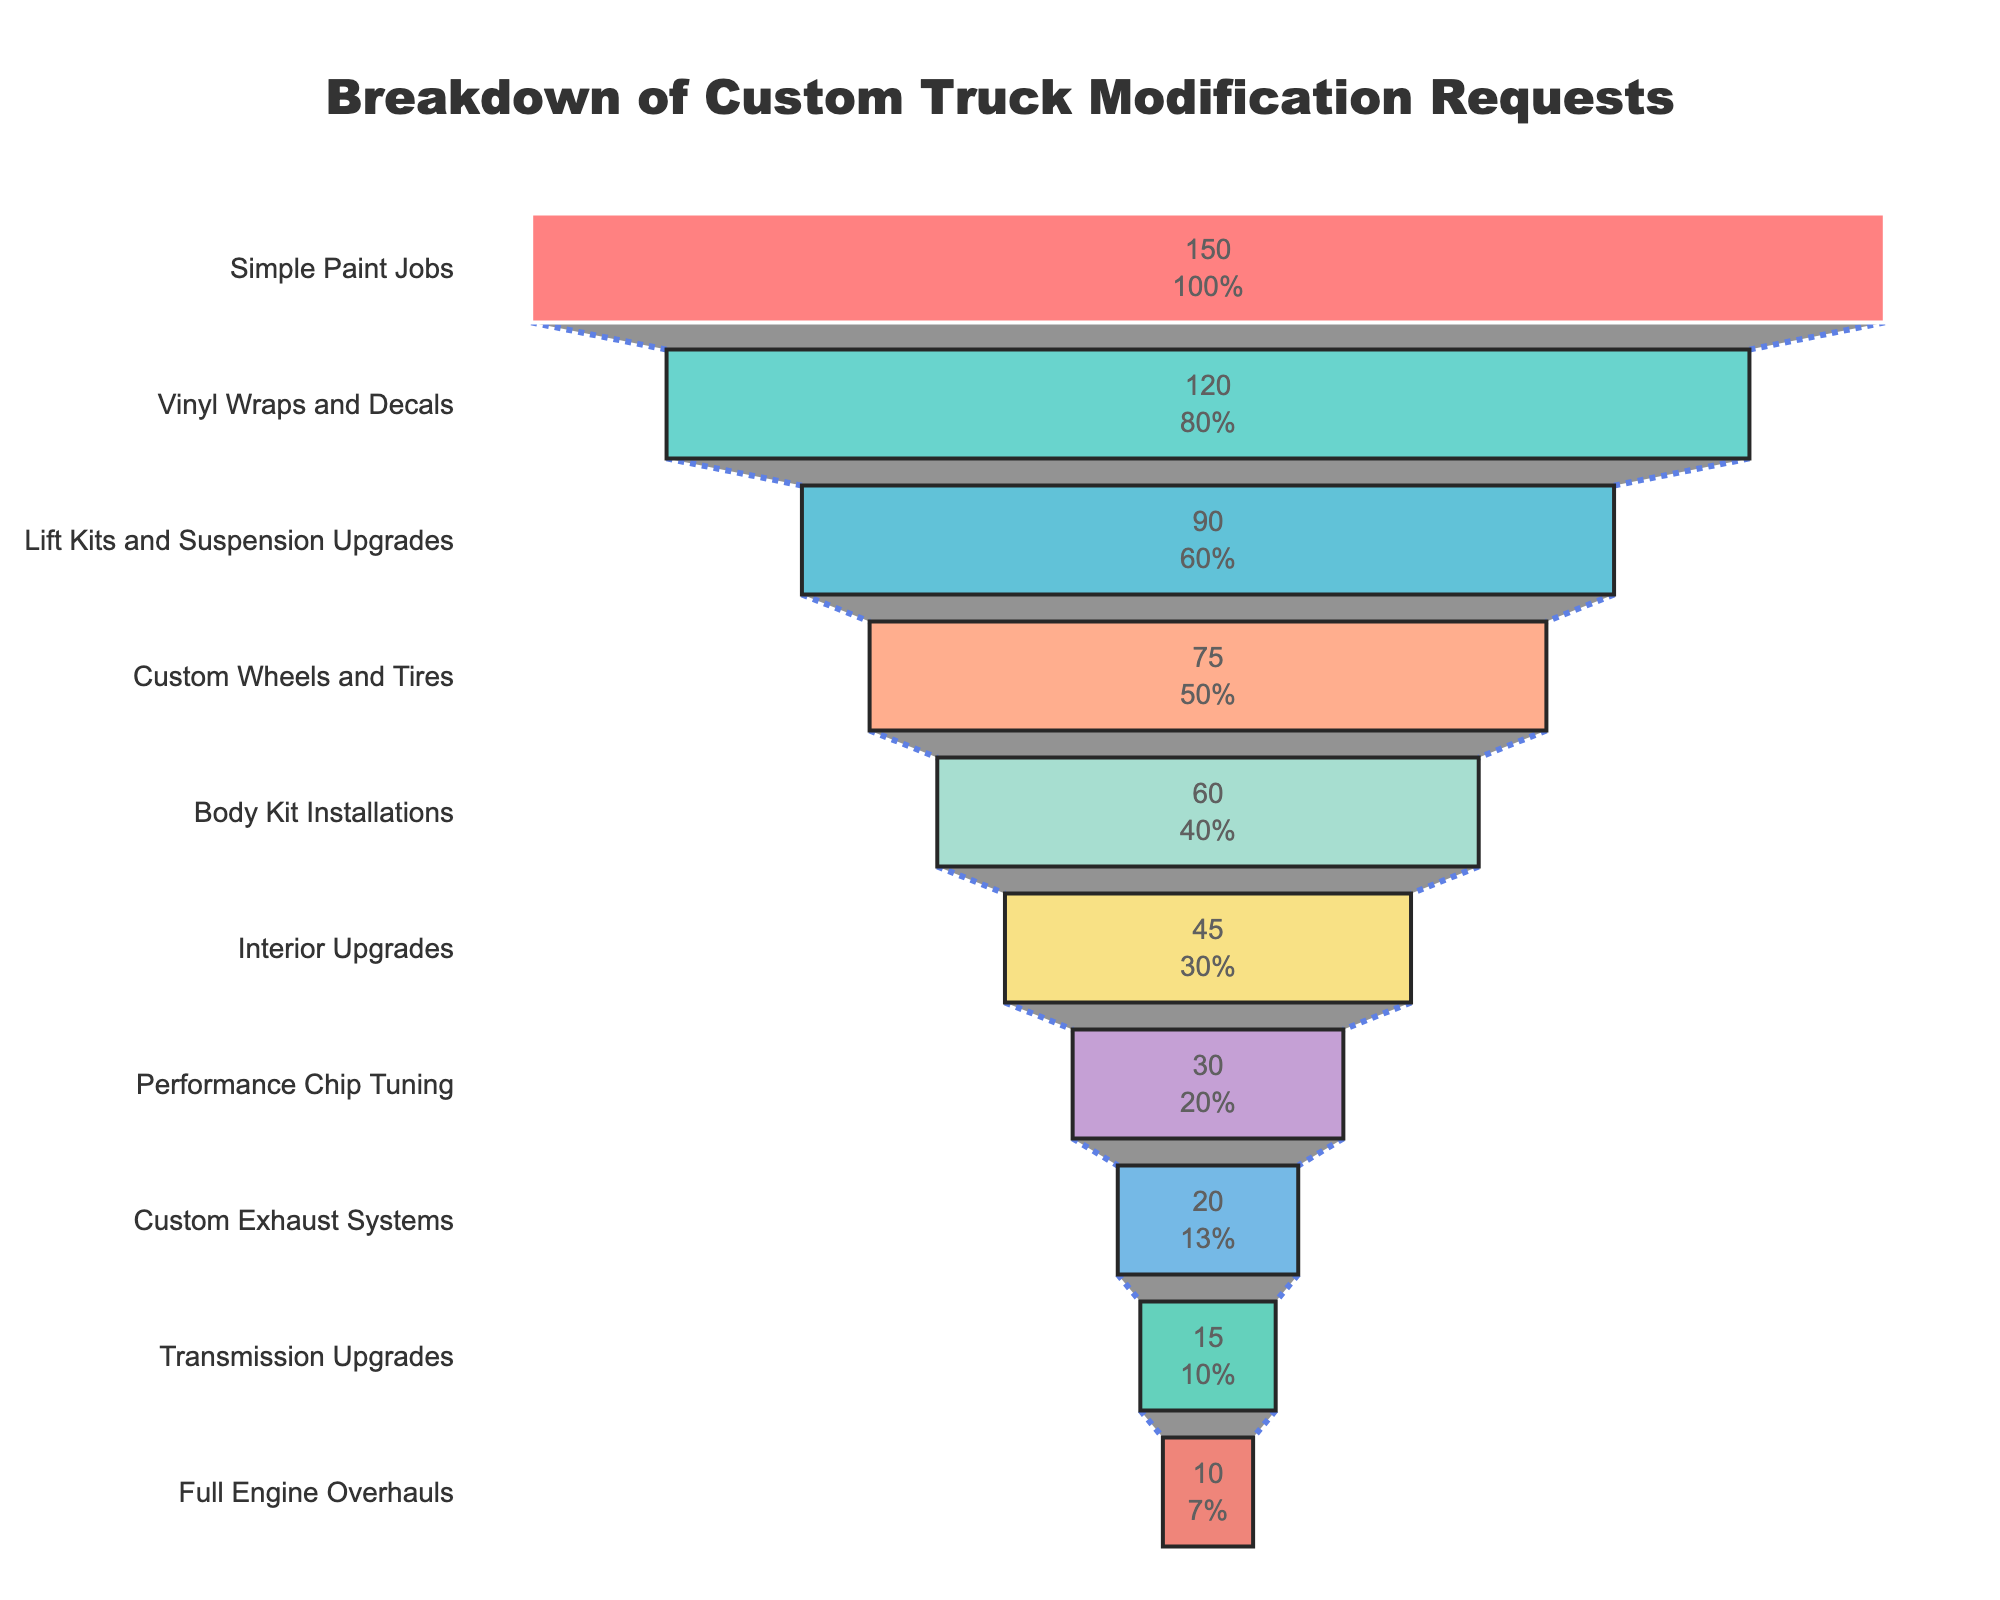What is the title of the chart? The title of the chart is located at the top and usually presents an overview of the chart's content. The title here is "Breakdown of Custom Truck Modification Requests".
Answer: Breakdown of Custom Truck Modification Requests Which modification type has the highest number of requests? The modification type with the highest number of requests is positioned at the widest part at the top of the funnel chart. It is labeled "Simple Paint Jobs" with 150 requests.
Answer: Simple Paint Jobs How many types of custom truck modifications are listed in the chart? The number of distinct modification types can be determined by counting each distinct section of the funnel chart from top to bottom. There are 10 different modification types listed.
Answer: 10 What percentage of total requests are for Lift Kits and Suspension Upgrades? The number of requests for Lift Kits and Suspension Upgrades is 90. To find the percentage, divide this by the total number of requests for all modification types and multiply by 100. The total number of requests is the sum of all values from the funnel chart: 150 + 120 + 90 + 75 + 60 + 45 + 30 + 20 + 15 + 10 = 615. The percentage is (90 / 615) * 100 ≈ 14.63%.
Answer: 14.63% Which modification type has the lowest number of requests and how many requests does it have? The modification type with the lowest number of requests is at the narrowest part at the bottom of the funnel chart. It is labeled "Full Engine Overhauls" with 10 requests.
Answer: Full Engine Overhauls, 10 How many more requests are there for Vinyl Wraps and Decals compared to Custom Exhaust Systems? Vinyl Wraps and Decals have 120 requests while Custom Exhaust Systems have 20 requests. Subtract the number of requests for Custom Exhaust Systems from Vinyl Wraps and Decals: 120 - 20 = 100.
Answer: 100 Arrange the modification types in descending order of requests. Order the modification types from the top to the bottom of the funnel chart based on the number of requests: 
1. Simple Paint Jobs
2. Vinyl Wraps and Decals
3. Lift Kits and Suspension Upgrades
4. Custom Wheels and Tires
5. Body Kit Installations
6. Interior Upgrades
7. Performance Chip Tuning
8. Custom Exhaust Systems
9. Transmission Upgrades
10. Full Engine Overhauls
Answer: Simple Paint Jobs, Vinyl Wraps and Decals, Lift Kits and Suspension Upgrades, Custom Wheels and Tires, Body Kit Installations, Interior Upgrades, Performance Chip Tuning, Custom Exhaust Systems, Transmission Upgrades, Full Engine Overhauls What is the sum of requests for Custom Wheels and Tires and Performance Chip Tuning? The number of requests for Custom Wheels and Tires is 75, and for Performance Chip Tuning is 30. Add these values together: 75 + 30 = 105.
Answer: 105 Which modification type follows Body Kit Installations in the funnel chart? The modification type directly following Body Kit Installations, which is positioned below it in the funnel chart, is Interior Upgrades.
Answer: Interior Upgrades 